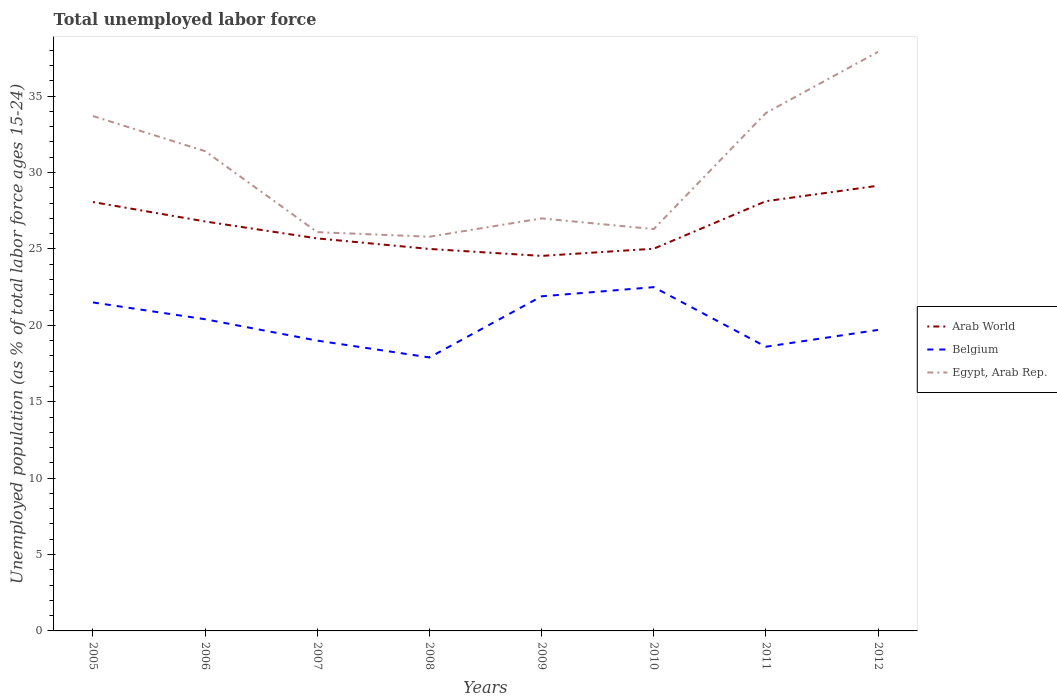Is the number of lines equal to the number of legend labels?
Provide a succinct answer. Yes. Across all years, what is the maximum percentage of unemployed population in in Arab World?
Offer a terse response. 24.55. What is the total percentage of unemployed population in in Arab World in the graph?
Give a very brief answer. -4.59. What is the difference between the highest and the second highest percentage of unemployed population in in Egypt, Arab Rep.?
Give a very brief answer. 12.1. What is the difference between the highest and the lowest percentage of unemployed population in in Egypt, Arab Rep.?
Your response must be concise. 4. Is the percentage of unemployed population in in Belgium strictly greater than the percentage of unemployed population in in Arab World over the years?
Your answer should be very brief. Yes. How many lines are there?
Offer a very short reply. 3. How many years are there in the graph?
Your answer should be very brief. 8. What is the difference between two consecutive major ticks on the Y-axis?
Keep it short and to the point. 5. Does the graph contain grids?
Offer a very short reply. No. How are the legend labels stacked?
Keep it short and to the point. Vertical. What is the title of the graph?
Your response must be concise. Total unemployed labor force. What is the label or title of the X-axis?
Keep it short and to the point. Years. What is the label or title of the Y-axis?
Provide a short and direct response. Unemployed population (as % of total labor force ages 15-24). What is the Unemployed population (as % of total labor force ages 15-24) in Arab World in 2005?
Keep it short and to the point. 28.07. What is the Unemployed population (as % of total labor force ages 15-24) in Belgium in 2005?
Provide a short and direct response. 21.5. What is the Unemployed population (as % of total labor force ages 15-24) of Egypt, Arab Rep. in 2005?
Give a very brief answer. 33.7. What is the Unemployed population (as % of total labor force ages 15-24) in Arab World in 2006?
Make the answer very short. 26.8. What is the Unemployed population (as % of total labor force ages 15-24) of Belgium in 2006?
Make the answer very short. 20.4. What is the Unemployed population (as % of total labor force ages 15-24) of Egypt, Arab Rep. in 2006?
Keep it short and to the point. 31.4. What is the Unemployed population (as % of total labor force ages 15-24) in Arab World in 2007?
Ensure brevity in your answer.  25.69. What is the Unemployed population (as % of total labor force ages 15-24) of Belgium in 2007?
Your answer should be very brief. 19. What is the Unemployed population (as % of total labor force ages 15-24) in Egypt, Arab Rep. in 2007?
Provide a short and direct response. 26.1. What is the Unemployed population (as % of total labor force ages 15-24) in Arab World in 2008?
Give a very brief answer. 25. What is the Unemployed population (as % of total labor force ages 15-24) in Belgium in 2008?
Make the answer very short. 17.9. What is the Unemployed population (as % of total labor force ages 15-24) in Egypt, Arab Rep. in 2008?
Offer a terse response. 25.8. What is the Unemployed population (as % of total labor force ages 15-24) of Arab World in 2009?
Ensure brevity in your answer.  24.55. What is the Unemployed population (as % of total labor force ages 15-24) in Belgium in 2009?
Offer a very short reply. 21.9. What is the Unemployed population (as % of total labor force ages 15-24) of Egypt, Arab Rep. in 2009?
Ensure brevity in your answer.  27. What is the Unemployed population (as % of total labor force ages 15-24) of Arab World in 2010?
Offer a terse response. 25.02. What is the Unemployed population (as % of total labor force ages 15-24) of Egypt, Arab Rep. in 2010?
Make the answer very short. 26.3. What is the Unemployed population (as % of total labor force ages 15-24) of Arab World in 2011?
Keep it short and to the point. 28.12. What is the Unemployed population (as % of total labor force ages 15-24) in Belgium in 2011?
Offer a terse response. 18.6. What is the Unemployed population (as % of total labor force ages 15-24) of Egypt, Arab Rep. in 2011?
Offer a very short reply. 33.9. What is the Unemployed population (as % of total labor force ages 15-24) of Arab World in 2012?
Provide a succinct answer. 29.14. What is the Unemployed population (as % of total labor force ages 15-24) in Belgium in 2012?
Make the answer very short. 19.7. What is the Unemployed population (as % of total labor force ages 15-24) in Egypt, Arab Rep. in 2012?
Your response must be concise. 37.9. Across all years, what is the maximum Unemployed population (as % of total labor force ages 15-24) in Arab World?
Your response must be concise. 29.14. Across all years, what is the maximum Unemployed population (as % of total labor force ages 15-24) in Egypt, Arab Rep.?
Provide a succinct answer. 37.9. Across all years, what is the minimum Unemployed population (as % of total labor force ages 15-24) of Arab World?
Give a very brief answer. 24.55. Across all years, what is the minimum Unemployed population (as % of total labor force ages 15-24) in Belgium?
Ensure brevity in your answer.  17.9. Across all years, what is the minimum Unemployed population (as % of total labor force ages 15-24) in Egypt, Arab Rep.?
Your answer should be very brief. 25.8. What is the total Unemployed population (as % of total labor force ages 15-24) in Arab World in the graph?
Make the answer very short. 212.38. What is the total Unemployed population (as % of total labor force ages 15-24) of Belgium in the graph?
Give a very brief answer. 161.5. What is the total Unemployed population (as % of total labor force ages 15-24) of Egypt, Arab Rep. in the graph?
Make the answer very short. 242.1. What is the difference between the Unemployed population (as % of total labor force ages 15-24) of Arab World in 2005 and that in 2006?
Give a very brief answer. 1.27. What is the difference between the Unemployed population (as % of total labor force ages 15-24) in Belgium in 2005 and that in 2006?
Your response must be concise. 1.1. What is the difference between the Unemployed population (as % of total labor force ages 15-24) in Arab World in 2005 and that in 2007?
Ensure brevity in your answer.  2.38. What is the difference between the Unemployed population (as % of total labor force ages 15-24) in Arab World in 2005 and that in 2008?
Your response must be concise. 3.07. What is the difference between the Unemployed population (as % of total labor force ages 15-24) in Belgium in 2005 and that in 2008?
Offer a terse response. 3.6. What is the difference between the Unemployed population (as % of total labor force ages 15-24) in Arab World in 2005 and that in 2009?
Ensure brevity in your answer.  3.53. What is the difference between the Unemployed population (as % of total labor force ages 15-24) in Arab World in 2005 and that in 2010?
Ensure brevity in your answer.  3.05. What is the difference between the Unemployed population (as % of total labor force ages 15-24) of Arab World in 2005 and that in 2011?
Keep it short and to the point. -0.05. What is the difference between the Unemployed population (as % of total labor force ages 15-24) in Belgium in 2005 and that in 2011?
Your answer should be compact. 2.9. What is the difference between the Unemployed population (as % of total labor force ages 15-24) in Egypt, Arab Rep. in 2005 and that in 2011?
Make the answer very short. -0.2. What is the difference between the Unemployed population (as % of total labor force ages 15-24) in Arab World in 2005 and that in 2012?
Your answer should be compact. -1.07. What is the difference between the Unemployed population (as % of total labor force ages 15-24) in Egypt, Arab Rep. in 2005 and that in 2012?
Provide a succinct answer. -4.2. What is the difference between the Unemployed population (as % of total labor force ages 15-24) of Arab World in 2006 and that in 2007?
Provide a short and direct response. 1.11. What is the difference between the Unemployed population (as % of total labor force ages 15-24) of Egypt, Arab Rep. in 2006 and that in 2007?
Your response must be concise. 5.3. What is the difference between the Unemployed population (as % of total labor force ages 15-24) in Arab World in 2006 and that in 2008?
Your answer should be compact. 1.8. What is the difference between the Unemployed population (as % of total labor force ages 15-24) of Belgium in 2006 and that in 2008?
Your answer should be compact. 2.5. What is the difference between the Unemployed population (as % of total labor force ages 15-24) of Egypt, Arab Rep. in 2006 and that in 2008?
Keep it short and to the point. 5.6. What is the difference between the Unemployed population (as % of total labor force ages 15-24) of Arab World in 2006 and that in 2009?
Give a very brief answer. 2.25. What is the difference between the Unemployed population (as % of total labor force ages 15-24) in Belgium in 2006 and that in 2009?
Give a very brief answer. -1.5. What is the difference between the Unemployed population (as % of total labor force ages 15-24) of Arab World in 2006 and that in 2010?
Give a very brief answer. 1.78. What is the difference between the Unemployed population (as % of total labor force ages 15-24) of Belgium in 2006 and that in 2010?
Your response must be concise. -2.1. What is the difference between the Unemployed population (as % of total labor force ages 15-24) of Arab World in 2006 and that in 2011?
Provide a succinct answer. -1.33. What is the difference between the Unemployed population (as % of total labor force ages 15-24) of Belgium in 2006 and that in 2011?
Give a very brief answer. 1.8. What is the difference between the Unemployed population (as % of total labor force ages 15-24) of Arab World in 2006 and that in 2012?
Provide a succinct answer. -2.34. What is the difference between the Unemployed population (as % of total labor force ages 15-24) of Belgium in 2006 and that in 2012?
Give a very brief answer. 0.7. What is the difference between the Unemployed population (as % of total labor force ages 15-24) in Egypt, Arab Rep. in 2006 and that in 2012?
Make the answer very short. -6.5. What is the difference between the Unemployed population (as % of total labor force ages 15-24) of Arab World in 2007 and that in 2008?
Keep it short and to the point. 0.69. What is the difference between the Unemployed population (as % of total labor force ages 15-24) of Arab World in 2007 and that in 2009?
Keep it short and to the point. 1.15. What is the difference between the Unemployed population (as % of total labor force ages 15-24) in Egypt, Arab Rep. in 2007 and that in 2009?
Give a very brief answer. -0.9. What is the difference between the Unemployed population (as % of total labor force ages 15-24) in Arab World in 2007 and that in 2010?
Ensure brevity in your answer.  0.67. What is the difference between the Unemployed population (as % of total labor force ages 15-24) in Egypt, Arab Rep. in 2007 and that in 2010?
Keep it short and to the point. -0.2. What is the difference between the Unemployed population (as % of total labor force ages 15-24) of Arab World in 2007 and that in 2011?
Your answer should be compact. -2.43. What is the difference between the Unemployed population (as % of total labor force ages 15-24) of Arab World in 2007 and that in 2012?
Your answer should be very brief. -3.45. What is the difference between the Unemployed population (as % of total labor force ages 15-24) in Egypt, Arab Rep. in 2007 and that in 2012?
Provide a short and direct response. -11.8. What is the difference between the Unemployed population (as % of total labor force ages 15-24) in Arab World in 2008 and that in 2009?
Your response must be concise. 0.46. What is the difference between the Unemployed population (as % of total labor force ages 15-24) of Belgium in 2008 and that in 2009?
Provide a short and direct response. -4. What is the difference between the Unemployed population (as % of total labor force ages 15-24) of Egypt, Arab Rep. in 2008 and that in 2009?
Offer a terse response. -1.2. What is the difference between the Unemployed population (as % of total labor force ages 15-24) of Arab World in 2008 and that in 2010?
Give a very brief answer. -0.01. What is the difference between the Unemployed population (as % of total labor force ages 15-24) of Arab World in 2008 and that in 2011?
Your response must be concise. -3.12. What is the difference between the Unemployed population (as % of total labor force ages 15-24) in Belgium in 2008 and that in 2011?
Your answer should be very brief. -0.7. What is the difference between the Unemployed population (as % of total labor force ages 15-24) in Egypt, Arab Rep. in 2008 and that in 2011?
Offer a very short reply. -8.1. What is the difference between the Unemployed population (as % of total labor force ages 15-24) of Arab World in 2008 and that in 2012?
Provide a short and direct response. -4.14. What is the difference between the Unemployed population (as % of total labor force ages 15-24) of Arab World in 2009 and that in 2010?
Make the answer very short. -0.47. What is the difference between the Unemployed population (as % of total labor force ages 15-24) in Belgium in 2009 and that in 2010?
Your answer should be compact. -0.6. What is the difference between the Unemployed population (as % of total labor force ages 15-24) of Arab World in 2009 and that in 2011?
Your answer should be very brief. -3.58. What is the difference between the Unemployed population (as % of total labor force ages 15-24) of Arab World in 2009 and that in 2012?
Your answer should be very brief. -4.59. What is the difference between the Unemployed population (as % of total labor force ages 15-24) in Arab World in 2010 and that in 2011?
Your answer should be very brief. -3.11. What is the difference between the Unemployed population (as % of total labor force ages 15-24) in Egypt, Arab Rep. in 2010 and that in 2011?
Your answer should be very brief. -7.6. What is the difference between the Unemployed population (as % of total labor force ages 15-24) in Arab World in 2010 and that in 2012?
Make the answer very short. -4.12. What is the difference between the Unemployed population (as % of total labor force ages 15-24) of Arab World in 2011 and that in 2012?
Make the answer very short. -1.01. What is the difference between the Unemployed population (as % of total labor force ages 15-24) of Belgium in 2011 and that in 2012?
Your response must be concise. -1.1. What is the difference between the Unemployed population (as % of total labor force ages 15-24) in Arab World in 2005 and the Unemployed population (as % of total labor force ages 15-24) in Belgium in 2006?
Your answer should be very brief. 7.67. What is the difference between the Unemployed population (as % of total labor force ages 15-24) in Arab World in 2005 and the Unemployed population (as % of total labor force ages 15-24) in Egypt, Arab Rep. in 2006?
Your answer should be very brief. -3.33. What is the difference between the Unemployed population (as % of total labor force ages 15-24) of Belgium in 2005 and the Unemployed population (as % of total labor force ages 15-24) of Egypt, Arab Rep. in 2006?
Offer a terse response. -9.9. What is the difference between the Unemployed population (as % of total labor force ages 15-24) of Arab World in 2005 and the Unemployed population (as % of total labor force ages 15-24) of Belgium in 2007?
Provide a succinct answer. 9.07. What is the difference between the Unemployed population (as % of total labor force ages 15-24) in Arab World in 2005 and the Unemployed population (as % of total labor force ages 15-24) in Egypt, Arab Rep. in 2007?
Your answer should be compact. 1.97. What is the difference between the Unemployed population (as % of total labor force ages 15-24) in Arab World in 2005 and the Unemployed population (as % of total labor force ages 15-24) in Belgium in 2008?
Offer a terse response. 10.17. What is the difference between the Unemployed population (as % of total labor force ages 15-24) in Arab World in 2005 and the Unemployed population (as % of total labor force ages 15-24) in Egypt, Arab Rep. in 2008?
Keep it short and to the point. 2.27. What is the difference between the Unemployed population (as % of total labor force ages 15-24) of Belgium in 2005 and the Unemployed population (as % of total labor force ages 15-24) of Egypt, Arab Rep. in 2008?
Provide a succinct answer. -4.3. What is the difference between the Unemployed population (as % of total labor force ages 15-24) in Arab World in 2005 and the Unemployed population (as % of total labor force ages 15-24) in Belgium in 2009?
Provide a succinct answer. 6.17. What is the difference between the Unemployed population (as % of total labor force ages 15-24) in Arab World in 2005 and the Unemployed population (as % of total labor force ages 15-24) in Egypt, Arab Rep. in 2009?
Your answer should be very brief. 1.07. What is the difference between the Unemployed population (as % of total labor force ages 15-24) of Belgium in 2005 and the Unemployed population (as % of total labor force ages 15-24) of Egypt, Arab Rep. in 2009?
Make the answer very short. -5.5. What is the difference between the Unemployed population (as % of total labor force ages 15-24) in Arab World in 2005 and the Unemployed population (as % of total labor force ages 15-24) in Belgium in 2010?
Provide a succinct answer. 5.57. What is the difference between the Unemployed population (as % of total labor force ages 15-24) of Arab World in 2005 and the Unemployed population (as % of total labor force ages 15-24) of Egypt, Arab Rep. in 2010?
Provide a succinct answer. 1.77. What is the difference between the Unemployed population (as % of total labor force ages 15-24) of Belgium in 2005 and the Unemployed population (as % of total labor force ages 15-24) of Egypt, Arab Rep. in 2010?
Your answer should be very brief. -4.8. What is the difference between the Unemployed population (as % of total labor force ages 15-24) of Arab World in 2005 and the Unemployed population (as % of total labor force ages 15-24) of Belgium in 2011?
Offer a very short reply. 9.47. What is the difference between the Unemployed population (as % of total labor force ages 15-24) of Arab World in 2005 and the Unemployed population (as % of total labor force ages 15-24) of Egypt, Arab Rep. in 2011?
Ensure brevity in your answer.  -5.83. What is the difference between the Unemployed population (as % of total labor force ages 15-24) in Belgium in 2005 and the Unemployed population (as % of total labor force ages 15-24) in Egypt, Arab Rep. in 2011?
Ensure brevity in your answer.  -12.4. What is the difference between the Unemployed population (as % of total labor force ages 15-24) of Arab World in 2005 and the Unemployed population (as % of total labor force ages 15-24) of Belgium in 2012?
Your response must be concise. 8.37. What is the difference between the Unemployed population (as % of total labor force ages 15-24) in Arab World in 2005 and the Unemployed population (as % of total labor force ages 15-24) in Egypt, Arab Rep. in 2012?
Offer a terse response. -9.83. What is the difference between the Unemployed population (as % of total labor force ages 15-24) of Belgium in 2005 and the Unemployed population (as % of total labor force ages 15-24) of Egypt, Arab Rep. in 2012?
Provide a short and direct response. -16.4. What is the difference between the Unemployed population (as % of total labor force ages 15-24) in Arab World in 2006 and the Unemployed population (as % of total labor force ages 15-24) in Belgium in 2007?
Offer a terse response. 7.8. What is the difference between the Unemployed population (as % of total labor force ages 15-24) of Arab World in 2006 and the Unemployed population (as % of total labor force ages 15-24) of Egypt, Arab Rep. in 2007?
Offer a terse response. 0.7. What is the difference between the Unemployed population (as % of total labor force ages 15-24) of Arab World in 2006 and the Unemployed population (as % of total labor force ages 15-24) of Belgium in 2008?
Ensure brevity in your answer.  8.9. What is the difference between the Unemployed population (as % of total labor force ages 15-24) of Belgium in 2006 and the Unemployed population (as % of total labor force ages 15-24) of Egypt, Arab Rep. in 2008?
Offer a very short reply. -5.4. What is the difference between the Unemployed population (as % of total labor force ages 15-24) of Arab World in 2006 and the Unemployed population (as % of total labor force ages 15-24) of Belgium in 2009?
Ensure brevity in your answer.  4.9. What is the difference between the Unemployed population (as % of total labor force ages 15-24) in Arab World in 2006 and the Unemployed population (as % of total labor force ages 15-24) in Egypt, Arab Rep. in 2009?
Provide a short and direct response. -0.2. What is the difference between the Unemployed population (as % of total labor force ages 15-24) in Belgium in 2006 and the Unemployed population (as % of total labor force ages 15-24) in Egypt, Arab Rep. in 2009?
Your response must be concise. -6.6. What is the difference between the Unemployed population (as % of total labor force ages 15-24) in Arab World in 2006 and the Unemployed population (as % of total labor force ages 15-24) in Belgium in 2010?
Your response must be concise. 4.3. What is the difference between the Unemployed population (as % of total labor force ages 15-24) of Arab World in 2006 and the Unemployed population (as % of total labor force ages 15-24) of Egypt, Arab Rep. in 2010?
Keep it short and to the point. 0.5. What is the difference between the Unemployed population (as % of total labor force ages 15-24) in Arab World in 2006 and the Unemployed population (as % of total labor force ages 15-24) in Belgium in 2011?
Make the answer very short. 8.2. What is the difference between the Unemployed population (as % of total labor force ages 15-24) of Arab World in 2006 and the Unemployed population (as % of total labor force ages 15-24) of Egypt, Arab Rep. in 2011?
Provide a short and direct response. -7.1. What is the difference between the Unemployed population (as % of total labor force ages 15-24) of Belgium in 2006 and the Unemployed population (as % of total labor force ages 15-24) of Egypt, Arab Rep. in 2011?
Make the answer very short. -13.5. What is the difference between the Unemployed population (as % of total labor force ages 15-24) of Arab World in 2006 and the Unemployed population (as % of total labor force ages 15-24) of Belgium in 2012?
Give a very brief answer. 7.1. What is the difference between the Unemployed population (as % of total labor force ages 15-24) of Arab World in 2006 and the Unemployed population (as % of total labor force ages 15-24) of Egypt, Arab Rep. in 2012?
Your answer should be very brief. -11.1. What is the difference between the Unemployed population (as % of total labor force ages 15-24) of Belgium in 2006 and the Unemployed population (as % of total labor force ages 15-24) of Egypt, Arab Rep. in 2012?
Keep it short and to the point. -17.5. What is the difference between the Unemployed population (as % of total labor force ages 15-24) in Arab World in 2007 and the Unemployed population (as % of total labor force ages 15-24) in Belgium in 2008?
Keep it short and to the point. 7.79. What is the difference between the Unemployed population (as % of total labor force ages 15-24) of Arab World in 2007 and the Unemployed population (as % of total labor force ages 15-24) of Egypt, Arab Rep. in 2008?
Offer a terse response. -0.11. What is the difference between the Unemployed population (as % of total labor force ages 15-24) in Arab World in 2007 and the Unemployed population (as % of total labor force ages 15-24) in Belgium in 2009?
Provide a succinct answer. 3.79. What is the difference between the Unemployed population (as % of total labor force ages 15-24) of Arab World in 2007 and the Unemployed population (as % of total labor force ages 15-24) of Egypt, Arab Rep. in 2009?
Your response must be concise. -1.31. What is the difference between the Unemployed population (as % of total labor force ages 15-24) in Belgium in 2007 and the Unemployed population (as % of total labor force ages 15-24) in Egypt, Arab Rep. in 2009?
Your answer should be compact. -8. What is the difference between the Unemployed population (as % of total labor force ages 15-24) in Arab World in 2007 and the Unemployed population (as % of total labor force ages 15-24) in Belgium in 2010?
Give a very brief answer. 3.19. What is the difference between the Unemployed population (as % of total labor force ages 15-24) of Arab World in 2007 and the Unemployed population (as % of total labor force ages 15-24) of Egypt, Arab Rep. in 2010?
Offer a terse response. -0.61. What is the difference between the Unemployed population (as % of total labor force ages 15-24) of Arab World in 2007 and the Unemployed population (as % of total labor force ages 15-24) of Belgium in 2011?
Make the answer very short. 7.09. What is the difference between the Unemployed population (as % of total labor force ages 15-24) in Arab World in 2007 and the Unemployed population (as % of total labor force ages 15-24) in Egypt, Arab Rep. in 2011?
Give a very brief answer. -8.21. What is the difference between the Unemployed population (as % of total labor force ages 15-24) of Belgium in 2007 and the Unemployed population (as % of total labor force ages 15-24) of Egypt, Arab Rep. in 2011?
Provide a succinct answer. -14.9. What is the difference between the Unemployed population (as % of total labor force ages 15-24) of Arab World in 2007 and the Unemployed population (as % of total labor force ages 15-24) of Belgium in 2012?
Your response must be concise. 5.99. What is the difference between the Unemployed population (as % of total labor force ages 15-24) of Arab World in 2007 and the Unemployed population (as % of total labor force ages 15-24) of Egypt, Arab Rep. in 2012?
Make the answer very short. -12.21. What is the difference between the Unemployed population (as % of total labor force ages 15-24) in Belgium in 2007 and the Unemployed population (as % of total labor force ages 15-24) in Egypt, Arab Rep. in 2012?
Make the answer very short. -18.9. What is the difference between the Unemployed population (as % of total labor force ages 15-24) of Arab World in 2008 and the Unemployed population (as % of total labor force ages 15-24) of Belgium in 2009?
Keep it short and to the point. 3.1. What is the difference between the Unemployed population (as % of total labor force ages 15-24) in Arab World in 2008 and the Unemployed population (as % of total labor force ages 15-24) in Egypt, Arab Rep. in 2009?
Make the answer very short. -2. What is the difference between the Unemployed population (as % of total labor force ages 15-24) in Belgium in 2008 and the Unemployed population (as % of total labor force ages 15-24) in Egypt, Arab Rep. in 2009?
Your answer should be compact. -9.1. What is the difference between the Unemployed population (as % of total labor force ages 15-24) of Arab World in 2008 and the Unemployed population (as % of total labor force ages 15-24) of Belgium in 2010?
Your response must be concise. 2.5. What is the difference between the Unemployed population (as % of total labor force ages 15-24) of Arab World in 2008 and the Unemployed population (as % of total labor force ages 15-24) of Egypt, Arab Rep. in 2010?
Your response must be concise. -1.3. What is the difference between the Unemployed population (as % of total labor force ages 15-24) in Arab World in 2008 and the Unemployed population (as % of total labor force ages 15-24) in Belgium in 2011?
Provide a short and direct response. 6.4. What is the difference between the Unemployed population (as % of total labor force ages 15-24) in Arab World in 2008 and the Unemployed population (as % of total labor force ages 15-24) in Egypt, Arab Rep. in 2011?
Make the answer very short. -8.9. What is the difference between the Unemployed population (as % of total labor force ages 15-24) in Arab World in 2008 and the Unemployed population (as % of total labor force ages 15-24) in Belgium in 2012?
Your answer should be very brief. 5.3. What is the difference between the Unemployed population (as % of total labor force ages 15-24) of Arab World in 2008 and the Unemployed population (as % of total labor force ages 15-24) of Egypt, Arab Rep. in 2012?
Keep it short and to the point. -12.9. What is the difference between the Unemployed population (as % of total labor force ages 15-24) in Belgium in 2008 and the Unemployed population (as % of total labor force ages 15-24) in Egypt, Arab Rep. in 2012?
Your response must be concise. -20. What is the difference between the Unemployed population (as % of total labor force ages 15-24) of Arab World in 2009 and the Unemployed population (as % of total labor force ages 15-24) of Belgium in 2010?
Your answer should be very brief. 2.04. What is the difference between the Unemployed population (as % of total labor force ages 15-24) in Arab World in 2009 and the Unemployed population (as % of total labor force ages 15-24) in Egypt, Arab Rep. in 2010?
Offer a terse response. -1.75. What is the difference between the Unemployed population (as % of total labor force ages 15-24) in Arab World in 2009 and the Unemployed population (as % of total labor force ages 15-24) in Belgium in 2011?
Keep it short and to the point. 5.95. What is the difference between the Unemployed population (as % of total labor force ages 15-24) in Arab World in 2009 and the Unemployed population (as % of total labor force ages 15-24) in Egypt, Arab Rep. in 2011?
Offer a very short reply. -9.36. What is the difference between the Unemployed population (as % of total labor force ages 15-24) of Belgium in 2009 and the Unemployed population (as % of total labor force ages 15-24) of Egypt, Arab Rep. in 2011?
Offer a very short reply. -12. What is the difference between the Unemployed population (as % of total labor force ages 15-24) of Arab World in 2009 and the Unemployed population (as % of total labor force ages 15-24) of Belgium in 2012?
Ensure brevity in your answer.  4.84. What is the difference between the Unemployed population (as % of total labor force ages 15-24) in Arab World in 2009 and the Unemployed population (as % of total labor force ages 15-24) in Egypt, Arab Rep. in 2012?
Make the answer very short. -13.36. What is the difference between the Unemployed population (as % of total labor force ages 15-24) in Belgium in 2009 and the Unemployed population (as % of total labor force ages 15-24) in Egypt, Arab Rep. in 2012?
Give a very brief answer. -16. What is the difference between the Unemployed population (as % of total labor force ages 15-24) of Arab World in 2010 and the Unemployed population (as % of total labor force ages 15-24) of Belgium in 2011?
Provide a short and direct response. 6.42. What is the difference between the Unemployed population (as % of total labor force ages 15-24) of Arab World in 2010 and the Unemployed population (as % of total labor force ages 15-24) of Egypt, Arab Rep. in 2011?
Provide a succinct answer. -8.88. What is the difference between the Unemployed population (as % of total labor force ages 15-24) in Arab World in 2010 and the Unemployed population (as % of total labor force ages 15-24) in Belgium in 2012?
Give a very brief answer. 5.32. What is the difference between the Unemployed population (as % of total labor force ages 15-24) of Arab World in 2010 and the Unemployed population (as % of total labor force ages 15-24) of Egypt, Arab Rep. in 2012?
Offer a very short reply. -12.88. What is the difference between the Unemployed population (as % of total labor force ages 15-24) in Belgium in 2010 and the Unemployed population (as % of total labor force ages 15-24) in Egypt, Arab Rep. in 2012?
Ensure brevity in your answer.  -15.4. What is the difference between the Unemployed population (as % of total labor force ages 15-24) of Arab World in 2011 and the Unemployed population (as % of total labor force ages 15-24) of Belgium in 2012?
Give a very brief answer. 8.42. What is the difference between the Unemployed population (as % of total labor force ages 15-24) of Arab World in 2011 and the Unemployed population (as % of total labor force ages 15-24) of Egypt, Arab Rep. in 2012?
Provide a short and direct response. -9.78. What is the difference between the Unemployed population (as % of total labor force ages 15-24) of Belgium in 2011 and the Unemployed population (as % of total labor force ages 15-24) of Egypt, Arab Rep. in 2012?
Your response must be concise. -19.3. What is the average Unemployed population (as % of total labor force ages 15-24) in Arab World per year?
Your answer should be compact. 26.55. What is the average Unemployed population (as % of total labor force ages 15-24) of Belgium per year?
Provide a short and direct response. 20.19. What is the average Unemployed population (as % of total labor force ages 15-24) in Egypt, Arab Rep. per year?
Your answer should be compact. 30.26. In the year 2005, what is the difference between the Unemployed population (as % of total labor force ages 15-24) in Arab World and Unemployed population (as % of total labor force ages 15-24) in Belgium?
Your answer should be compact. 6.57. In the year 2005, what is the difference between the Unemployed population (as % of total labor force ages 15-24) of Arab World and Unemployed population (as % of total labor force ages 15-24) of Egypt, Arab Rep.?
Provide a succinct answer. -5.63. In the year 2005, what is the difference between the Unemployed population (as % of total labor force ages 15-24) of Belgium and Unemployed population (as % of total labor force ages 15-24) of Egypt, Arab Rep.?
Offer a very short reply. -12.2. In the year 2006, what is the difference between the Unemployed population (as % of total labor force ages 15-24) in Arab World and Unemployed population (as % of total labor force ages 15-24) in Belgium?
Provide a succinct answer. 6.4. In the year 2006, what is the difference between the Unemployed population (as % of total labor force ages 15-24) in Arab World and Unemployed population (as % of total labor force ages 15-24) in Egypt, Arab Rep.?
Make the answer very short. -4.6. In the year 2006, what is the difference between the Unemployed population (as % of total labor force ages 15-24) in Belgium and Unemployed population (as % of total labor force ages 15-24) in Egypt, Arab Rep.?
Make the answer very short. -11. In the year 2007, what is the difference between the Unemployed population (as % of total labor force ages 15-24) of Arab World and Unemployed population (as % of total labor force ages 15-24) of Belgium?
Your response must be concise. 6.69. In the year 2007, what is the difference between the Unemployed population (as % of total labor force ages 15-24) of Arab World and Unemployed population (as % of total labor force ages 15-24) of Egypt, Arab Rep.?
Provide a short and direct response. -0.41. In the year 2007, what is the difference between the Unemployed population (as % of total labor force ages 15-24) of Belgium and Unemployed population (as % of total labor force ages 15-24) of Egypt, Arab Rep.?
Offer a terse response. -7.1. In the year 2008, what is the difference between the Unemployed population (as % of total labor force ages 15-24) in Arab World and Unemployed population (as % of total labor force ages 15-24) in Belgium?
Your response must be concise. 7.1. In the year 2008, what is the difference between the Unemployed population (as % of total labor force ages 15-24) in Arab World and Unemployed population (as % of total labor force ages 15-24) in Egypt, Arab Rep.?
Offer a terse response. -0.8. In the year 2009, what is the difference between the Unemployed population (as % of total labor force ages 15-24) in Arab World and Unemployed population (as % of total labor force ages 15-24) in Belgium?
Offer a very short reply. 2.65. In the year 2009, what is the difference between the Unemployed population (as % of total labor force ages 15-24) in Arab World and Unemployed population (as % of total labor force ages 15-24) in Egypt, Arab Rep.?
Provide a succinct answer. -2.46. In the year 2009, what is the difference between the Unemployed population (as % of total labor force ages 15-24) in Belgium and Unemployed population (as % of total labor force ages 15-24) in Egypt, Arab Rep.?
Offer a terse response. -5.1. In the year 2010, what is the difference between the Unemployed population (as % of total labor force ages 15-24) of Arab World and Unemployed population (as % of total labor force ages 15-24) of Belgium?
Offer a very short reply. 2.52. In the year 2010, what is the difference between the Unemployed population (as % of total labor force ages 15-24) in Arab World and Unemployed population (as % of total labor force ages 15-24) in Egypt, Arab Rep.?
Your response must be concise. -1.28. In the year 2010, what is the difference between the Unemployed population (as % of total labor force ages 15-24) in Belgium and Unemployed population (as % of total labor force ages 15-24) in Egypt, Arab Rep.?
Your answer should be very brief. -3.8. In the year 2011, what is the difference between the Unemployed population (as % of total labor force ages 15-24) in Arab World and Unemployed population (as % of total labor force ages 15-24) in Belgium?
Make the answer very short. 9.52. In the year 2011, what is the difference between the Unemployed population (as % of total labor force ages 15-24) of Arab World and Unemployed population (as % of total labor force ages 15-24) of Egypt, Arab Rep.?
Keep it short and to the point. -5.78. In the year 2011, what is the difference between the Unemployed population (as % of total labor force ages 15-24) of Belgium and Unemployed population (as % of total labor force ages 15-24) of Egypt, Arab Rep.?
Your response must be concise. -15.3. In the year 2012, what is the difference between the Unemployed population (as % of total labor force ages 15-24) in Arab World and Unemployed population (as % of total labor force ages 15-24) in Belgium?
Your answer should be compact. 9.44. In the year 2012, what is the difference between the Unemployed population (as % of total labor force ages 15-24) in Arab World and Unemployed population (as % of total labor force ages 15-24) in Egypt, Arab Rep.?
Provide a short and direct response. -8.76. In the year 2012, what is the difference between the Unemployed population (as % of total labor force ages 15-24) in Belgium and Unemployed population (as % of total labor force ages 15-24) in Egypt, Arab Rep.?
Offer a very short reply. -18.2. What is the ratio of the Unemployed population (as % of total labor force ages 15-24) of Arab World in 2005 to that in 2006?
Keep it short and to the point. 1.05. What is the ratio of the Unemployed population (as % of total labor force ages 15-24) of Belgium in 2005 to that in 2006?
Provide a short and direct response. 1.05. What is the ratio of the Unemployed population (as % of total labor force ages 15-24) in Egypt, Arab Rep. in 2005 to that in 2006?
Offer a terse response. 1.07. What is the ratio of the Unemployed population (as % of total labor force ages 15-24) in Arab World in 2005 to that in 2007?
Make the answer very short. 1.09. What is the ratio of the Unemployed population (as % of total labor force ages 15-24) in Belgium in 2005 to that in 2007?
Offer a very short reply. 1.13. What is the ratio of the Unemployed population (as % of total labor force ages 15-24) of Egypt, Arab Rep. in 2005 to that in 2007?
Your answer should be compact. 1.29. What is the ratio of the Unemployed population (as % of total labor force ages 15-24) of Arab World in 2005 to that in 2008?
Provide a short and direct response. 1.12. What is the ratio of the Unemployed population (as % of total labor force ages 15-24) in Belgium in 2005 to that in 2008?
Make the answer very short. 1.2. What is the ratio of the Unemployed population (as % of total labor force ages 15-24) in Egypt, Arab Rep. in 2005 to that in 2008?
Offer a terse response. 1.31. What is the ratio of the Unemployed population (as % of total labor force ages 15-24) of Arab World in 2005 to that in 2009?
Ensure brevity in your answer.  1.14. What is the ratio of the Unemployed population (as % of total labor force ages 15-24) of Belgium in 2005 to that in 2009?
Ensure brevity in your answer.  0.98. What is the ratio of the Unemployed population (as % of total labor force ages 15-24) in Egypt, Arab Rep. in 2005 to that in 2009?
Provide a short and direct response. 1.25. What is the ratio of the Unemployed population (as % of total labor force ages 15-24) in Arab World in 2005 to that in 2010?
Your answer should be compact. 1.12. What is the ratio of the Unemployed population (as % of total labor force ages 15-24) of Belgium in 2005 to that in 2010?
Make the answer very short. 0.96. What is the ratio of the Unemployed population (as % of total labor force ages 15-24) of Egypt, Arab Rep. in 2005 to that in 2010?
Make the answer very short. 1.28. What is the ratio of the Unemployed population (as % of total labor force ages 15-24) in Arab World in 2005 to that in 2011?
Make the answer very short. 1. What is the ratio of the Unemployed population (as % of total labor force ages 15-24) of Belgium in 2005 to that in 2011?
Your answer should be very brief. 1.16. What is the ratio of the Unemployed population (as % of total labor force ages 15-24) of Egypt, Arab Rep. in 2005 to that in 2011?
Provide a short and direct response. 0.99. What is the ratio of the Unemployed population (as % of total labor force ages 15-24) of Arab World in 2005 to that in 2012?
Provide a short and direct response. 0.96. What is the ratio of the Unemployed population (as % of total labor force ages 15-24) in Belgium in 2005 to that in 2012?
Your answer should be very brief. 1.09. What is the ratio of the Unemployed population (as % of total labor force ages 15-24) of Egypt, Arab Rep. in 2005 to that in 2012?
Keep it short and to the point. 0.89. What is the ratio of the Unemployed population (as % of total labor force ages 15-24) of Arab World in 2006 to that in 2007?
Keep it short and to the point. 1.04. What is the ratio of the Unemployed population (as % of total labor force ages 15-24) in Belgium in 2006 to that in 2007?
Your answer should be compact. 1.07. What is the ratio of the Unemployed population (as % of total labor force ages 15-24) in Egypt, Arab Rep. in 2006 to that in 2007?
Make the answer very short. 1.2. What is the ratio of the Unemployed population (as % of total labor force ages 15-24) in Arab World in 2006 to that in 2008?
Ensure brevity in your answer.  1.07. What is the ratio of the Unemployed population (as % of total labor force ages 15-24) of Belgium in 2006 to that in 2008?
Offer a very short reply. 1.14. What is the ratio of the Unemployed population (as % of total labor force ages 15-24) of Egypt, Arab Rep. in 2006 to that in 2008?
Offer a very short reply. 1.22. What is the ratio of the Unemployed population (as % of total labor force ages 15-24) in Arab World in 2006 to that in 2009?
Offer a very short reply. 1.09. What is the ratio of the Unemployed population (as % of total labor force ages 15-24) of Belgium in 2006 to that in 2009?
Ensure brevity in your answer.  0.93. What is the ratio of the Unemployed population (as % of total labor force ages 15-24) of Egypt, Arab Rep. in 2006 to that in 2009?
Give a very brief answer. 1.16. What is the ratio of the Unemployed population (as % of total labor force ages 15-24) in Arab World in 2006 to that in 2010?
Your answer should be compact. 1.07. What is the ratio of the Unemployed population (as % of total labor force ages 15-24) in Belgium in 2006 to that in 2010?
Ensure brevity in your answer.  0.91. What is the ratio of the Unemployed population (as % of total labor force ages 15-24) of Egypt, Arab Rep. in 2006 to that in 2010?
Provide a short and direct response. 1.19. What is the ratio of the Unemployed population (as % of total labor force ages 15-24) of Arab World in 2006 to that in 2011?
Give a very brief answer. 0.95. What is the ratio of the Unemployed population (as % of total labor force ages 15-24) in Belgium in 2006 to that in 2011?
Make the answer very short. 1.1. What is the ratio of the Unemployed population (as % of total labor force ages 15-24) of Egypt, Arab Rep. in 2006 to that in 2011?
Provide a short and direct response. 0.93. What is the ratio of the Unemployed population (as % of total labor force ages 15-24) in Arab World in 2006 to that in 2012?
Keep it short and to the point. 0.92. What is the ratio of the Unemployed population (as % of total labor force ages 15-24) of Belgium in 2006 to that in 2012?
Your response must be concise. 1.04. What is the ratio of the Unemployed population (as % of total labor force ages 15-24) of Egypt, Arab Rep. in 2006 to that in 2012?
Your answer should be compact. 0.83. What is the ratio of the Unemployed population (as % of total labor force ages 15-24) in Arab World in 2007 to that in 2008?
Give a very brief answer. 1.03. What is the ratio of the Unemployed population (as % of total labor force ages 15-24) of Belgium in 2007 to that in 2008?
Make the answer very short. 1.06. What is the ratio of the Unemployed population (as % of total labor force ages 15-24) in Egypt, Arab Rep. in 2007 to that in 2008?
Offer a terse response. 1.01. What is the ratio of the Unemployed population (as % of total labor force ages 15-24) of Arab World in 2007 to that in 2009?
Your response must be concise. 1.05. What is the ratio of the Unemployed population (as % of total labor force ages 15-24) of Belgium in 2007 to that in 2009?
Ensure brevity in your answer.  0.87. What is the ratio of the Unemployed population (as % of total labor force ages 15-24) of Egypt, Arab Rep. in 2007 to that in 2009?
Provide a short and direct response. 0.97. What is the ratio of the Unemployed population (as % of total labor force ages 15-24) in Belgium in 2007 to that in 2010?
Provide a short and direct response. 0.84. What is the ratio of the Unemployed population (as % of total labor force ages 15-24) of Arab World in 2007 to that in 2011?
Offer a terse response. 0.91. What is the ratio of the Unemployed population (as % of total labor force ages 15-24) in Belgium in 2007 to that in 2011?
Keep it short and to the point. 1.02. What is the ratio of the Unemployed population (as % of total labor force ages 15-24) in Egypt, Arab Rep. in 2007 to that in 2011?
Your answer should be compact. 0.77. What is the ratio of the Unemployed population (as % of total labor force ages 15-24) of Arab World in 2007 to that in 2012?
Your answer should be compact. 0.88. What is the ratio of the Unemployed population (as % of total labor force ages 15-24) in Belgium in 2007 to that in 2012?
Ensure brevity in your answer.  0.96. What is the ratio of the Unemployed population (as % of total labor force ages 15-24) of Egypt, Arab Rep. in 2007 to that in 2012?
Offer a very short reply. 0.69. What is the ratio of the Unemployed population (as % of total labor force ages 15-24) of Arab World in 2008 to that in 2009?
Provide a short and direct response. 1.02. What is the ratio of the Unemployed population (as % of total labor force ages 15-24) in Belgium in 2008 to that in 2009?
Give a very brief answer. 0.82. What is the ratio of the Unemployed population (as % of total labor force ages 15-24) of Egypt, Arab Rep. in 2008 to that in 2009?
Offer a very short reply. 0.96. What is the ratio of the Unemployed population (as % of total labor force ages 15-24) in Arab World in 2008 to that in 2010?
Provide a succinct answer. 1. What is the ratio of the Unemployed population (as % of total labor force ages 15-24) in Belgium in 2008 to that in 2010?
Ensure brevity in your answer.  0.8. What is the ratio of the Unemployed population (as % of total labor force ages 15-24) in Belgium in 2008 to that in 2011?
Provide a short and direct response. 0.96. What is the ratio of the Unemployed population (as % of total labor force ages 15-24) in Egypt, Arab Rep. in 2008 to that in 2011?
Provide a short and direct response. 0.76. What is the ratio of the Unemployed population (as % of total labor force ages 15-24) in Arab World in 2008 to that in 2012?
Your answer should be compact. 0.86. What is the ratio of the Unemployed population (as % of total labor force ages 15-24) in Belgium in 2008 to that in 2012?
Make the answer very short. 0.91. What is the ratio of the Unemployed population (as % of total labor force ages 15-24) of Egypt, Arab Rep. in 2008 to that in 2012?
Provide a short and direct response. 0.68. What is the ratio of the Unemployed population (as % of total labor force ages 15-24) of Arab World in 2009 to that in 2010?
Offer a very short reply. 0.98. What is the ratio of the Unemployed population (as % of total labor force ages 15-24) in Belgium in 2009 to that in 2010?
Your answer should be very brief. 0.97. What is the ratio of the Unemployed population (as % of total labor force ages 15-24) in Egypt, Arab Rep. in 2009 to that in 2010?
Keep it short and to the point. 1.03. What is the ratio of the Unemployed population (as % of total labor force ages 15-24) of Arab World in 2009 to that in 2011?
Offer a very short reply. 0.87. What is the ratio of the Unemployed population (as % of total labor force ages 15-24) of Belgium in 2009 to that in 2011?
Your response must be concise. 1.18. What is the ratio of the Unemployed population (as % of total labor force ages 15-24) of Egypt, Arab Rep. in 2009 to that in 2011?
Your answer should be very brief. 0.8. What is the ratio of the Unemployed population (as % of total labor force ages 15-24) in Arab World in 2009 to that in 2012?
Your response must be concise. 0.84. What is the ratio of the Unemployed population (as % of total labor force ages 15-24) in Belgium in 2009 to that in 2012?
Give a very brief answer. 1.11. What is the ratio of the Unemployed population (as % of total labor force ages 15-24) of Egypt, Arab Rep. in 2009 to that in 2012?
Provide a succinct answer. 0.71. What is the ratio of the Unemployed population (as % of total labor force ages 15-24) in Arab World in 2010 to that in 2011?
Your answer should be compact. 0.89. What is the ratio of the Unemployed population (as % of total labor force ages 15-24) of Belgium in 2010 to that in 2011?
Your answer should be compact. 1.21. What is the ratio of the Unemployed population (as % of total labor force ages 15-24) of Egypt, Arab Rep. in 2010 to that in 2011?
Offer a very short reply. 0.78. What is the ratio of the Unemployed population (as % of total labor force ages 15-24) in Arab World in 2010 to that in 2012?
Provide a succinct answer. 0.86. What is the ratio of the Unemployed population (as % of total labor force ages 15-24) of Belgium in 2010 to that in 2012?
Provide a succinct answer. 1.14. What is the ratio of the Unemployed population (as % of total labor force ages 15-24) in Egypt, Arab Rep. in 2010 to that in 2012?
Your answer should be compact. 0.69. What is the ratio of the Unemployed population (as % of total labor force ages 15-24) of Arab World in 2011 to that in 2012?
Keep it short and to the point. 0.97. What is the ratio of the Unemployed population (as % of total labor force ages 15-24) in Belgium in 2011 to that in 2012?
Keep it short and to the point. 0.94. What is the ratio of the Unemployed population (as % of total labor force ages 15-24) of Egypt, Arab Rep. in 2011 to that in 2012?
Offer a terse response. 0.89. What is the difference between the highest and the second highest Unemployed population (as % of total labor force ages 15-24) in Arab World?
Ensure brevity in your answer.  1.01. What is the difference between the highest and the second highest Unemployed population (as % of total labor force ages 15-24) in Belgium?
Provide a short and direct response. 0.6. What is the difference between the highest and the second highest Unemployed population (as % of total labor force ages 15-24) in Egypt, Arab Rep.?
Give a very brief answer. 4. What is the difference between the highest and the lowest Unemployed population (as % of total labor force ages 15-24) in Arab World?
Offer a terse response. 4.59. What is the difference between the highest and the lowest Unemployed population (as % of total labor force ages 15-24) of Belgium?
Make the answer very short. 4.6. 